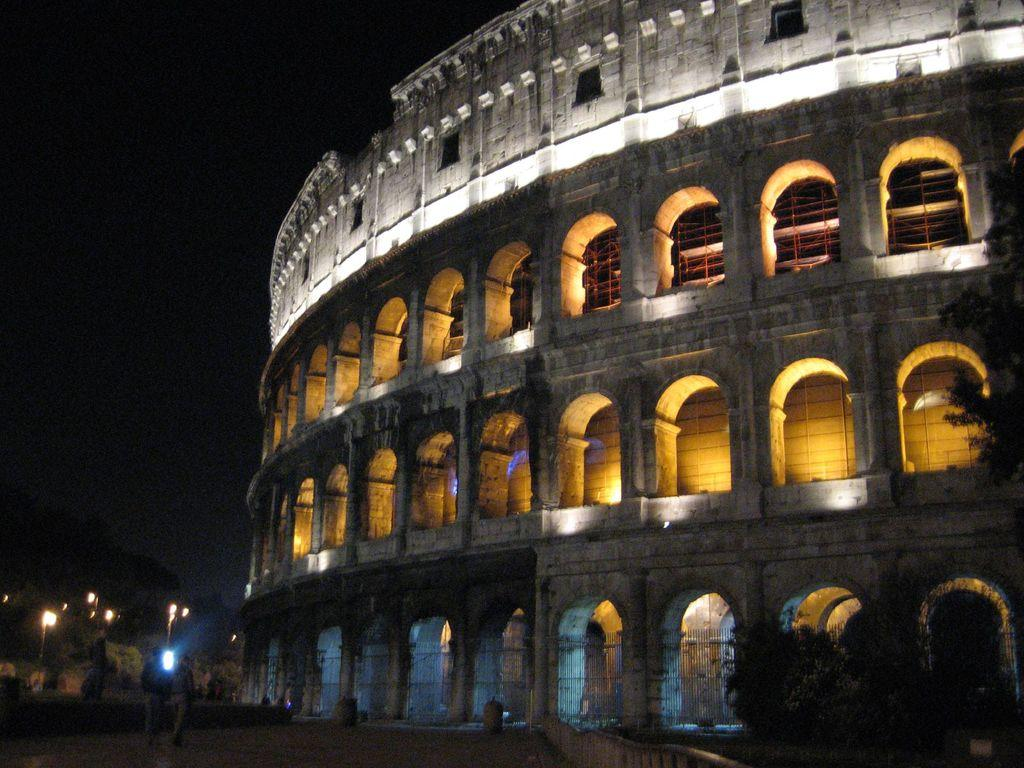What is the main structure in the picture? There is a building in the picture. What are the people in the picture doing? There are people walking in the picture. What feature of the building? Lights are attached to the building. How would you describe the sky in the picture? The sky is dark in the picture. What type of sticks can be seen in the image? There are no sticks present in the image. 